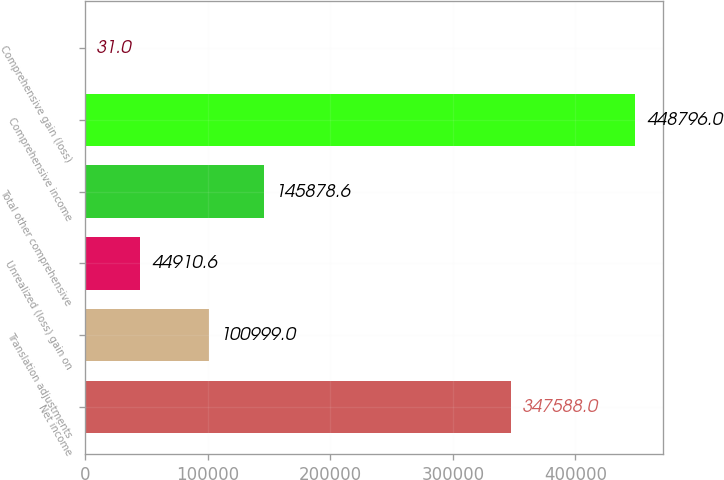Convert chart. <chart><loc_0><loc_0><loc_500><loc_500><bar_chart><fcel>Net income<fcel>Translation adjustments<fcel>Unrealized (loss) gain on<fcel>Total other comprehensive<fcel>Comprehensive income<fcel>Comprehensive gain (loss)<nl><fcel>347588<fcel>100999<fcel>44910.6<fcel>145879<fcel>448796<fcel>31<nl></chart> 